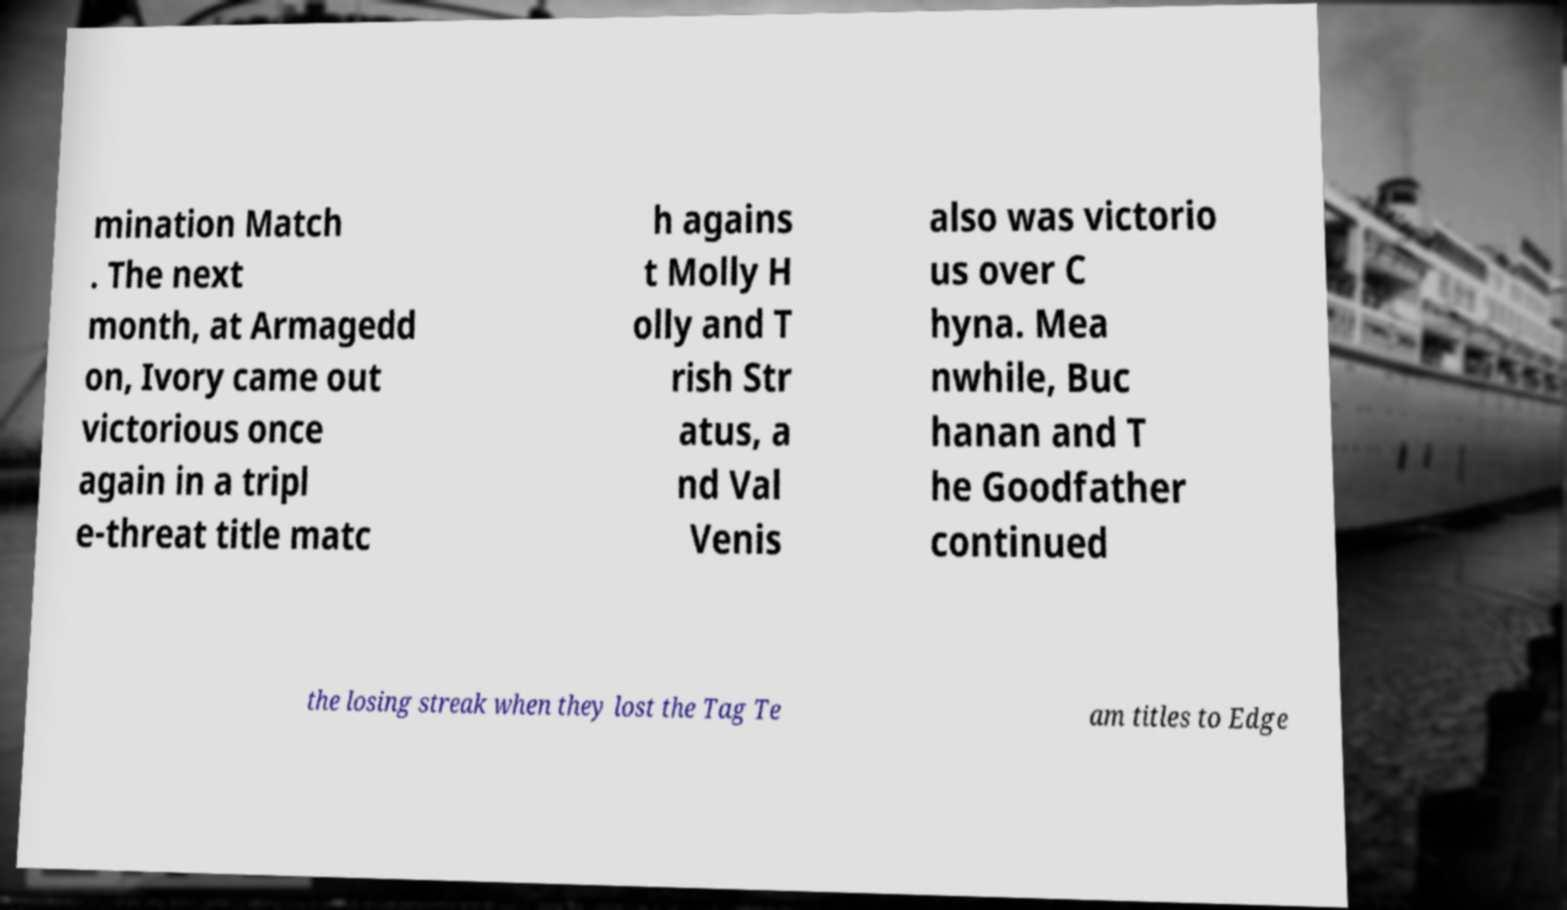There's text embedded in this image that I need extracted. Can you transcribe it verbatim? mination Match . The next month, at Armagedd on, Ivory came out victorious once again in a tripl e-threat title matc h agains t Molly H olly and T rish Str atus, a nd Val Venis also was victorio us over C hyna. Mea nwhile, Buc hanan and T he Goodfather continued the losing streak when they lost the Tag Te am titles to Edge 